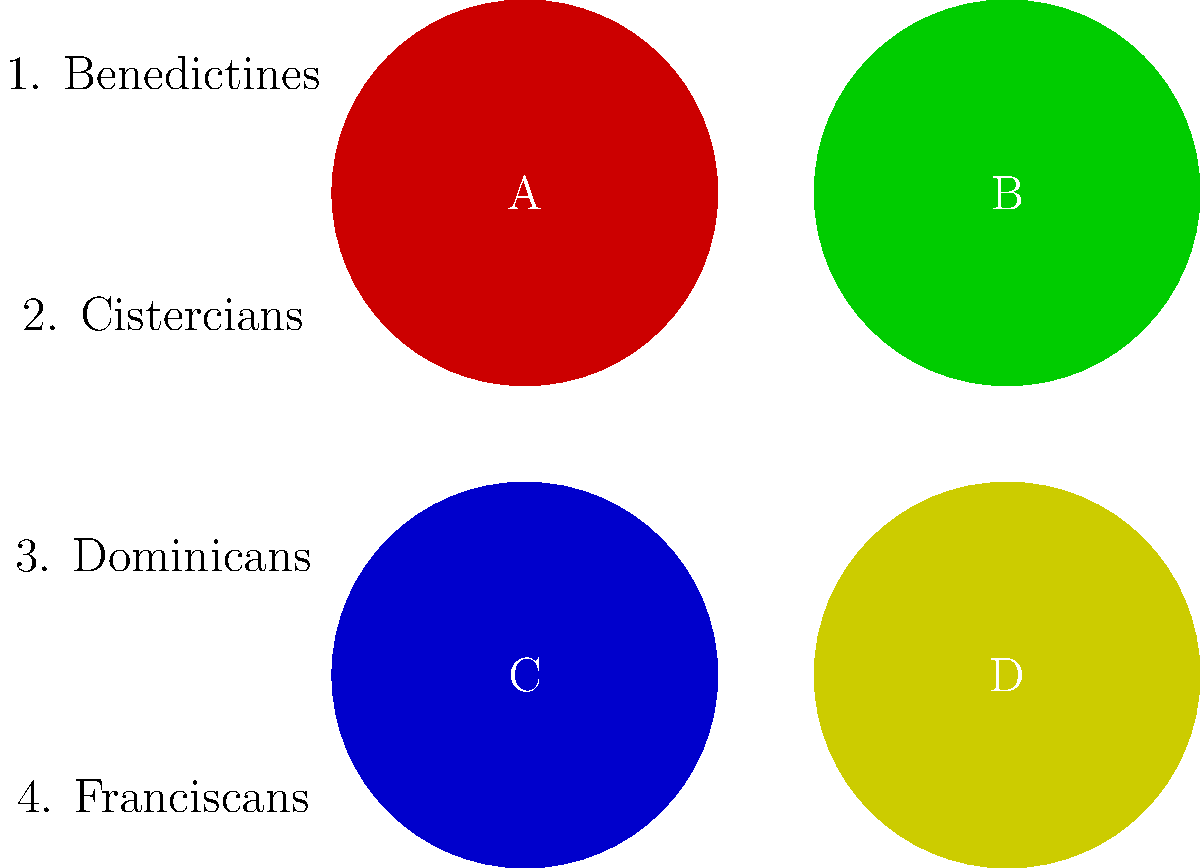Match the Christian monastic orders to their emblems, represented by colored circles. Which color corresponds to the Cistercians, known for their austere lifestyle and reform of the Benedictine order in medieval Europe? To answer this question, we need to consider the characteristics and historical context of each monastic order:

1. Benedictines: Founded by St. Benedict in the 6th century, they are often associated with the color black due to their black habits. This doesn't match any of the given colors.

2. Cistercians: Established in 1098 as a reform of the Benedictine order, they are known for their austere lifestyle and simplicity. They wore undyed wool habits, which appeared white or off-white. This corresponds to color A (red) in the image.

3. Dominicans: Founded in the 13th century, they are known as the "Order of Preachers." Their habit is white with a black cloak, often represented by the colors black and white together. This doesn't match any single color in the image.

4. Franciscans: Founded by St. Francis of Assisi in the 13th century, they are associated with the color brown due to their brown habits. This doesn't match any of the given colors.

By process of elimination and considering the Cistercians' association with white (the closest match being the light red circle), we can conclude that the Cistercians are represented by color A (red) in the image.
Answer: A (red) 